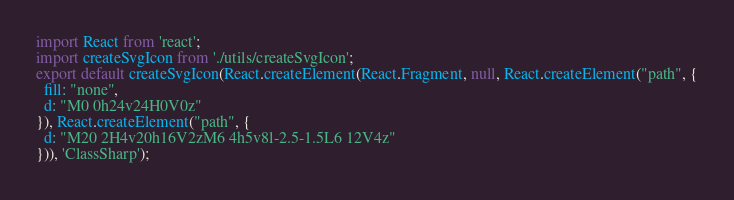<code> <loc_0><loc_0><loc_500><loc_500><_JavaScript_>import React from 'react';
import createSvgIcon from './utils/createSvgIcon';
export default createSvgIcon(React.createElement(React.Fragment, null, React.createElement("path", {
  fill: "none",
  d: "M0 0h24v24H0V0z"
}), React.createElement("path", {
  d: "M20 2H4v20h16V2zM6 4h5v8l-2.5-1.5L6 12V4z"
})), 'ClassSharp');</code> 